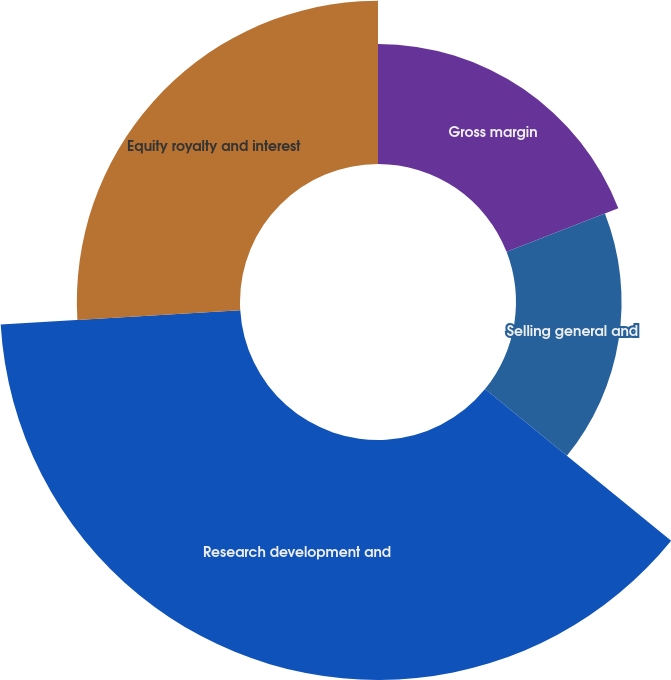Convert chart to OTSL. <chart><loc_0><loc_0><loc_500><loc_500><pie_chart><fcel>Gross margin<fcel>Selling general and<fcel>Research development and<fcel>Equity royalty and interest<nl><fcel>19.08%<fcel>16.79%<fcel>38.17%<fcel>25.95%<nl></chart> 